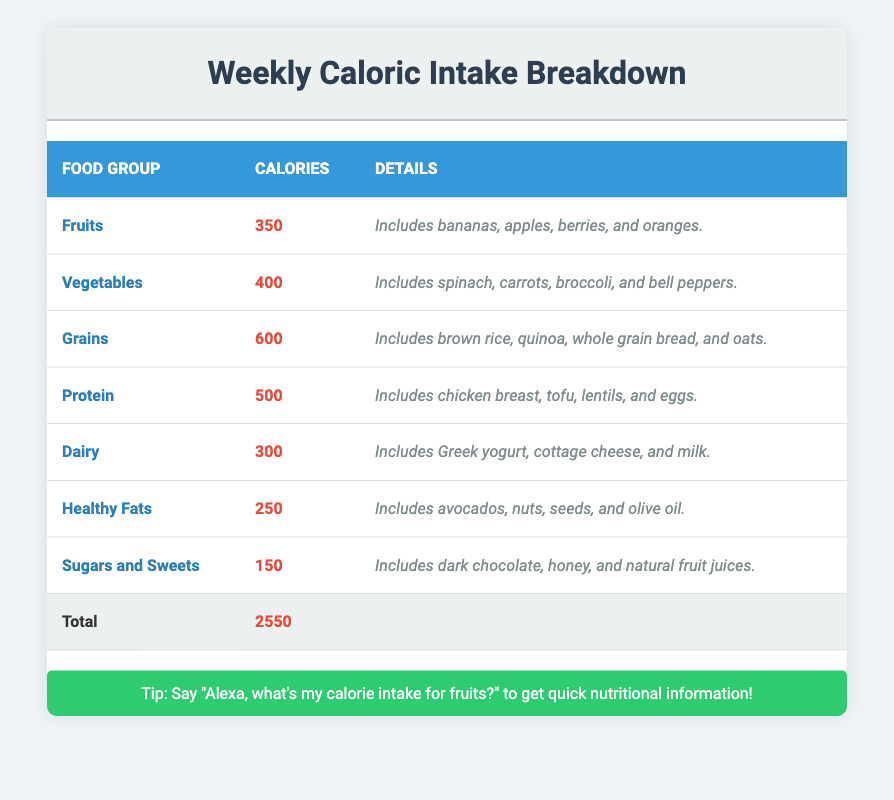What is the total caloric intake from all food groups? The total caloric intake is found by adding the calorie values from each food group: 350 + 400 + 600 + 500 + 300 + 250 + 150 = 2550 calories.
Answer: 2550 Which food group has the highest caloric intake? By reviewing the table, the highest caloric intake is from the Grains group, which has 600 calories.
Answer: Grains What percentage of the total caloric intake comes from Sugars and Sweets? Sugars and Sweets account for 150 calories. To find the percentage, use the formula (150/2550) * 100, which equals approximately 5.88%.
Answer: Approximately 5.88% Is the caloric intake for Dairy greater than the total for Healthy Fats? Dairy has 300 calories and Healthy Fats has 250 calories. Since 300 > 250, the statement is true.
Answer: Yes What is the average caloric intake per food group? There are 7 food groups, and their total caloric intake is 2550 calories. The average is calculated as 2550/7, which gives approximately 364.29 calories per group.
Answer: Approximately 364.29 If I ate 400 calories from Vegetables this week, how much more can I eat from the rest of the food groups? If I consumed 400 calories from Vegetables, I subtract that from the total intake of 2550 calories: 2550 - 400 = 2150 calories remaining to consume across the other food groups.
Answer: 2150 Which food group has the least caloric intake, and how much is it? The food group with the least caloric intake is Sugars and Sweets, which has 150 calories.
Answer: Sugars and Sweets, 150 calories How many more calories do Grains provide compared to Healthy Fats? Grains provide 600 calories while Healthy Fats provide 250 calories. The difference is calculated as 600 - 250 = 350 calories.
Answer: 350 Does the combined caloric intake of Fruits and Dairy exceed that of Protein? Fruits have 350 calories and Dairy has 300 calories, which together sum up to 650 calories. Protein has 500 calories. Since 650 > 500, the statement is true.
Answer: Yes 